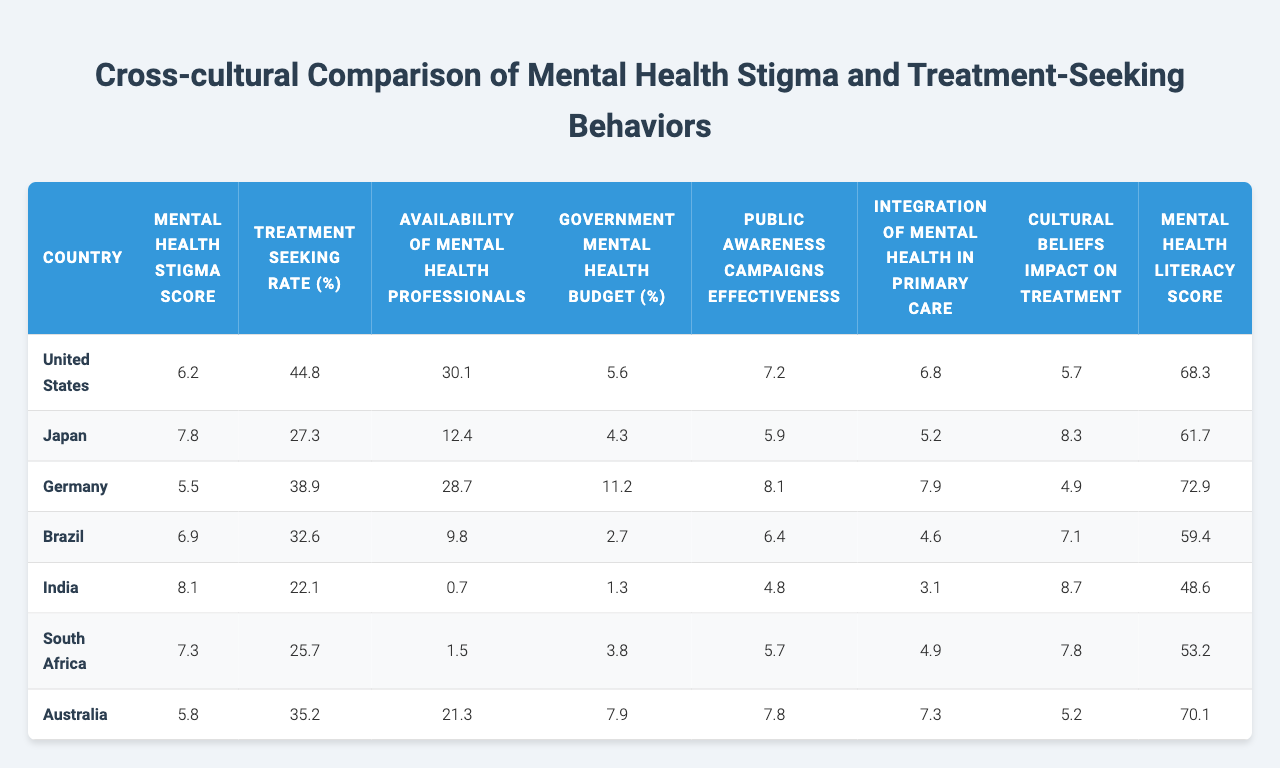What is the mental health stigma score for Japan? The table lists the mental health stigma score for each country. For Japan, the value is directly visible as 7.8.
Answer: 7.8 Which country has the highest treatment-seeking rate? By comparing the treatment-seeking rates listed in the table, the highest value is 44.8, which belongs to the United States.
Answer: United States What is the average mental health literacy score across all countries? Adding the mental health literacy scores (68.3 + 61.7 + 72.9 + 59.4 + 48.6 + 53.2 + 70.1 = 404.2) and dividing by 7 gives an average of approximately 57.7.
Answer: 57.7 Does Brazil have a higher or lower availability of mental health professionals compared to India? Brazil has an availability score of 9.8, while India has just 0.7, indicating that Brazil has a higher availability of mental health professionals.
Answer: Higher Which country has the lowest government mental health budget percentage? Looking at the values in the table, India has the lowest government mental health budget percentage at 1.3%.
Answer: India What is the difference in mental health stigma scores between South Africa and Japan? The stigma score for South Africa is 7.3 and for Japan is 7.8. The difference is 7.8 - 7.3 = 0.5.
Answer: 0.5 Which country has the highest effectiveness in public awareness campaigns? The table shows public awareness campaign effectiveness scores, with Germany rated at 8.1, the highest among the listed countries.
Answer: Germany Are cultural beliefs impacting treatment more in India than in Germany? India has a cultural beliefs impact score of 8.7, whereas Germany has a score of 4.9. Since 8.7 is greater than 4.9, the answer is yes.
Answer: Yes What is the median availability of mental health professionals across all countries? Arranging the availability scores (0.7, 1.5, 9.8, 12.4, 21.3, 28.7, 30.1) in order, the median value is the average of the 3rd and 4th values (9.8 + 12.4)/2 = 11.1.
Answer: 11.1 Is there a correlation between mental health stigma score and treatment-seeking rate based on the data? A high stigma score correlates mostly with a low treatment-seeking rate, especially noteworthy between India (8.1 stigma, 22.1 rate) and the United States (6.2 stigma, 44.8 rate).
Answer: Yes 